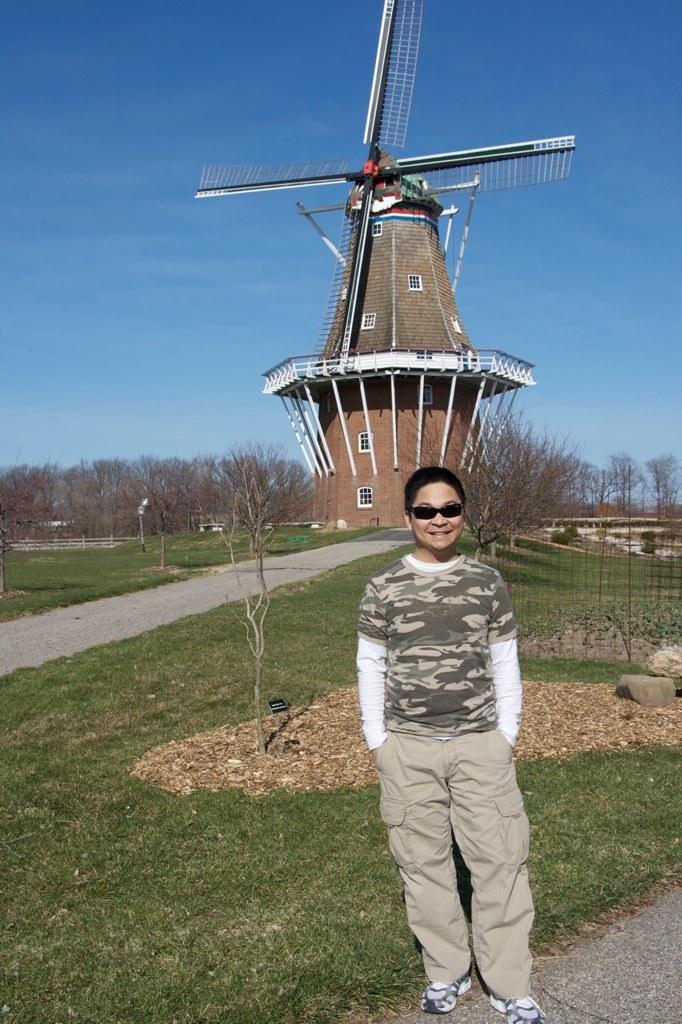Please provide a concise description of this image. In this image there is a man standing, in the background there is grassland and a path trees and a windmill, behind that there is the sky. 